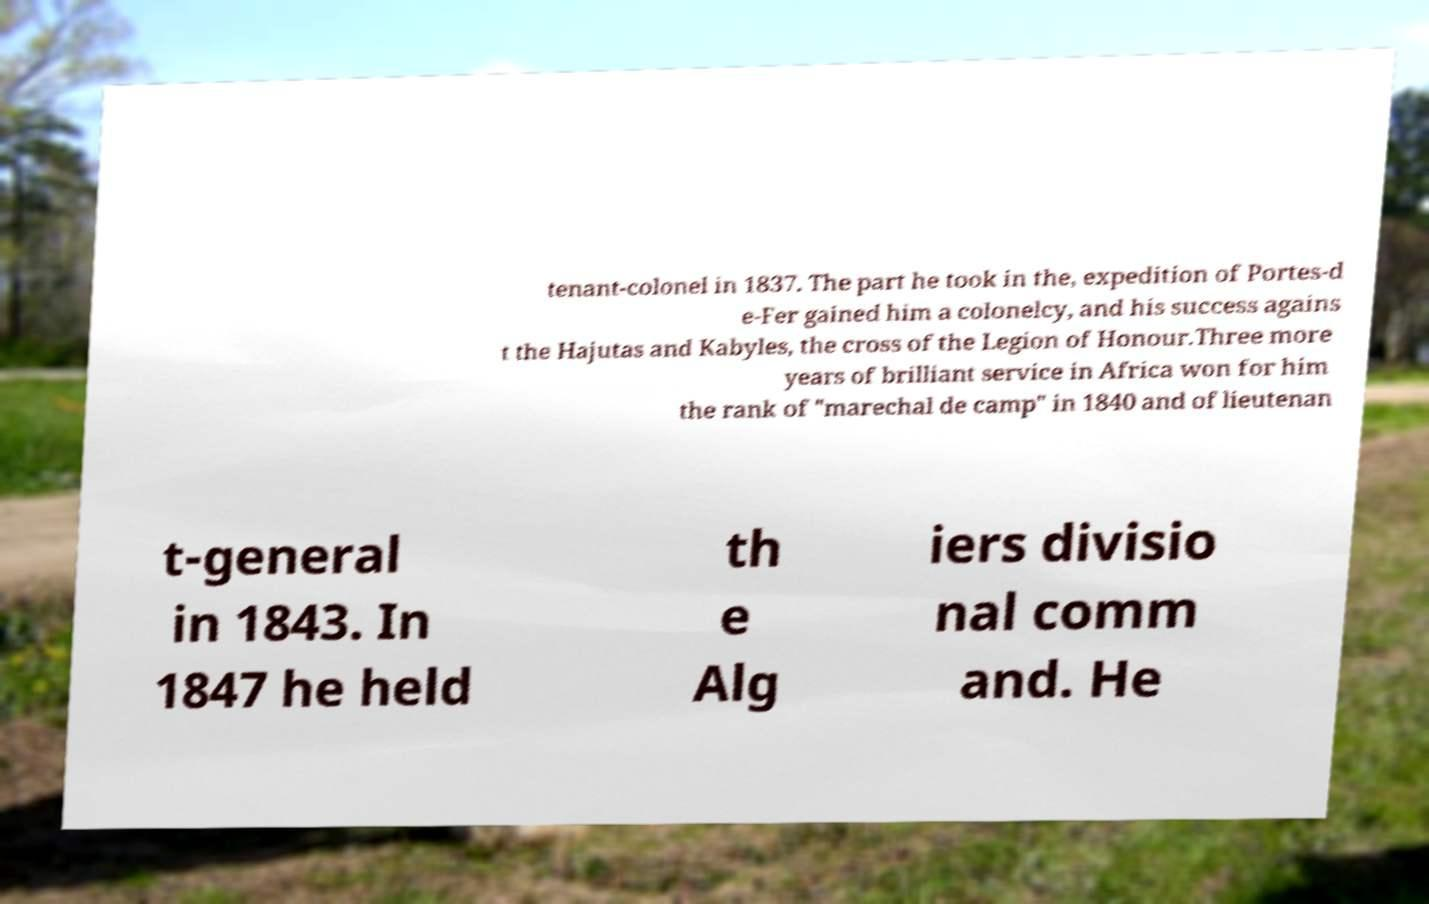Can you accurately transcribe the text from the provided image for me? tenant-colonel in 1837. The part he took in the, expedition of Portes-d e-Fer gained him a colonelcy, and his success agains t the Hajutas and Kabyles, the cross of the Legion of Honour.Three more years of brilliant service in Africa won for him the rank of "marechal de camp" in 1840 and of lieutenan t-general in 1843. In 1847 he held th e Alg iers divisio nal comm and. He 